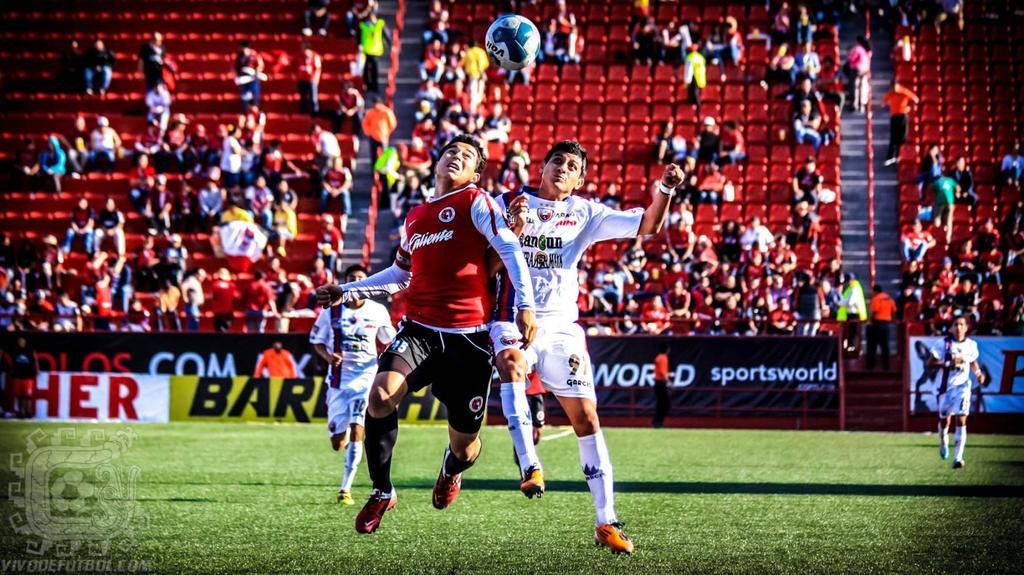<image>
Offer a succinct explanation of the picture presented. Two soccer players jump to headbutt the ball in front of a yellow banner that has BAR on it. 